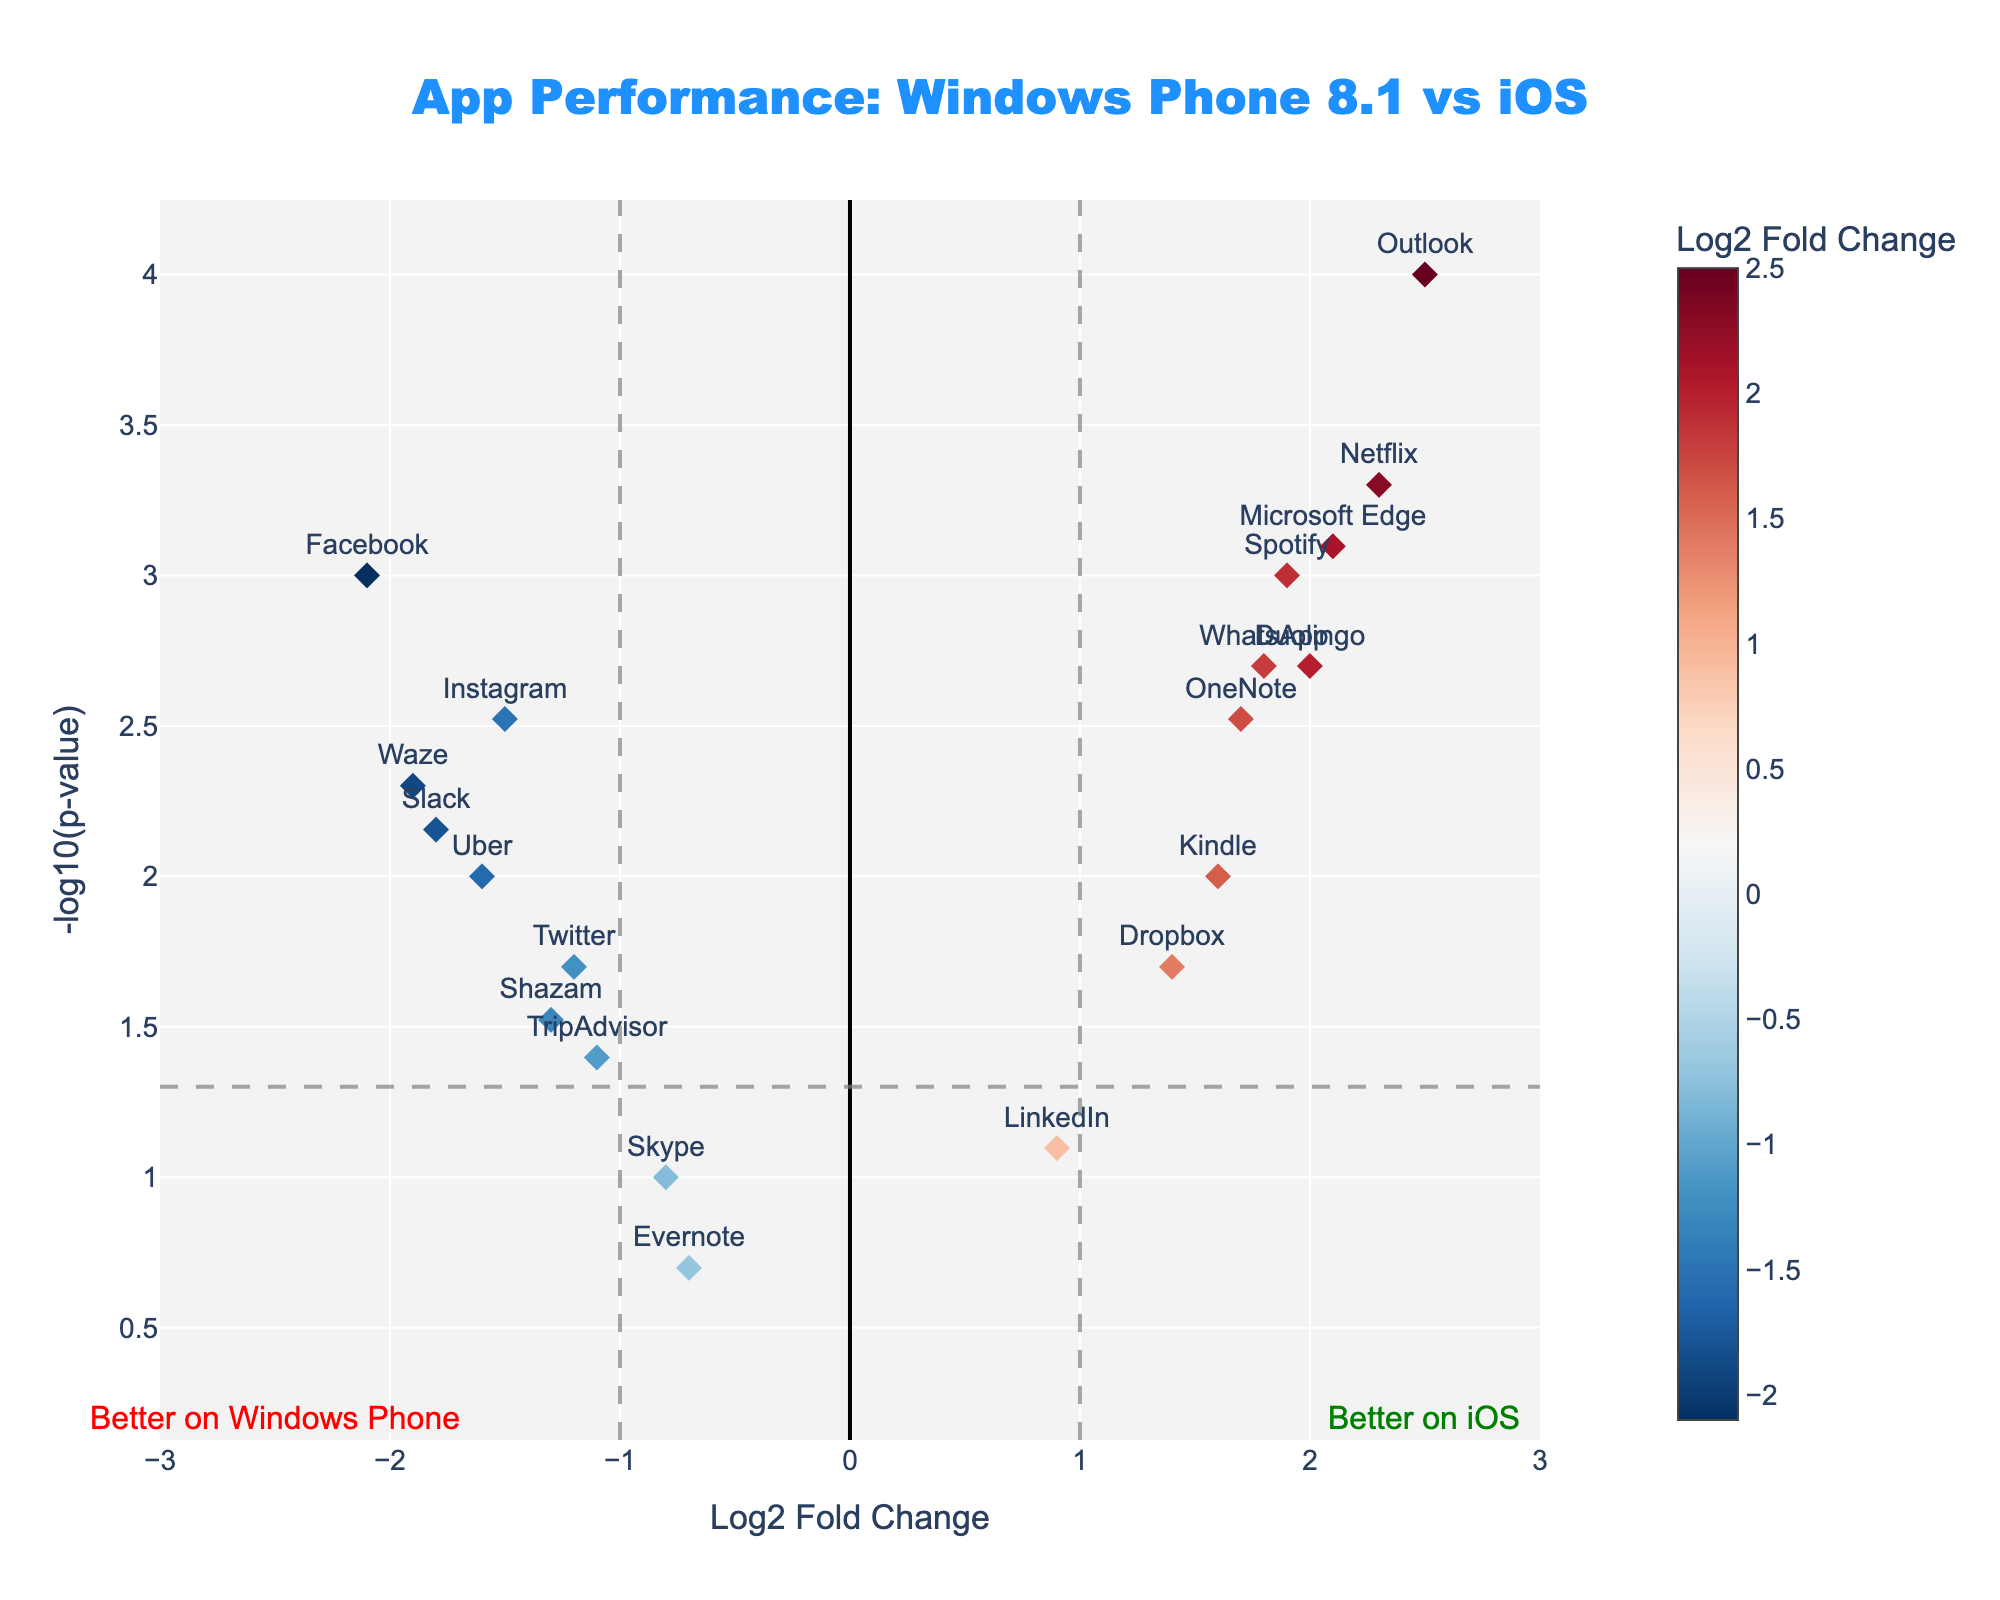What's the title of the plot? The title is found at the top center of the plot and it indicates the context or the main subject of the plot. It reads "App Performance: Windows Phone 8.1 vs iOS".
Answer: App Performance: Windows Phone 8.1 vs iOS What do the colors of the markers represent? The colors represent the Log2 Fold Change, which is indicated by the color scale bar on the right side of the plot. Apps with improved performance on iOS are in warmer colors (reds) while those with improved performance on Windows Phone are in cooler colors (blues).
Answer: Log2 Fold Change Which app has the highest -log10(p-value) and what is its value? To find this, look for the marker with the highest y-axis value. The Outlook app is positioned at the highest point on the y-axis. The exact value for -log10(p-value) can be obtained from the hover text of the Outlook app or the p-value provided in the dataset. Given p-value = 0.0001, -log10(0.0001) = 4.
Answer: Outlook, 4 Which app shows the most significant improvement on iOS? Significant improvement on iOS means a high positive Log2 Fold Change value combined with a low p-value. Outlook has the highest Log2 Fold Change of 2.5 with a very low p-value of 0.0001.
Answer: Outlook Which apps are significantly degraded on Windows Phone 8.1? Apps significantly degraded on Windows Phone 8.1 will have a high negative Log2 Fold Change and a low p-value (below the horizontal dashed line at p=0.05). These include Facebook, Instagram, Waze, Uber, and Slack.
Answer: Facebook, Instagram, Waze, Uber, Slack How many apps perform better on iOS compared to Windows Phone 8.1? Apps with a Log2 Fold Change greater than 0 (right side of the plot) indicate better performance on iOS. By counting these markers: WhatsApp, Netflix, Spotify, Outlook, OneNote, Microsoft Edge, Dropbox, Kindle, Duolingo.
Answer: 9 What is the Log2 Fold Change value for Skype, and is it significant? Look at the position of the Skype marker. According to the data, Skype has a Log2 Fold Change of -0.8. The p-value is 0.1, which makes it not significant as it lies above the horizontal dashed line at p=0.05.
Answer: -0.8, not significant Which app has the closest Log2 Fold Change to 0? You need to find the app whose marker is nearest to the vertical line at Log2 Fold Change = 0. LinkedIn with a Log2 Fold Change of 0.9 is closest to 0 compared to others.
Answer: LinkedIn Where is the marker for "Duolingo" located relative to the vertical dashed lines? Duolingo is located between the vertical dashed lines at Log2 Fold Change = 1 and Log2 Fold Change = 2, specifically at a Log2 Fold Change of 2.
Answer: Between 1 and 2 Which app has the smallest negative Log2 Fold Change and is it significant? The app with the smallest negative Log2 Fold Change is Evernote at -0.7. To determine the significance, check its p-value (0.2). It is not significant since it lies above the p=0.05 line.
Answer: Evernote, not significant 